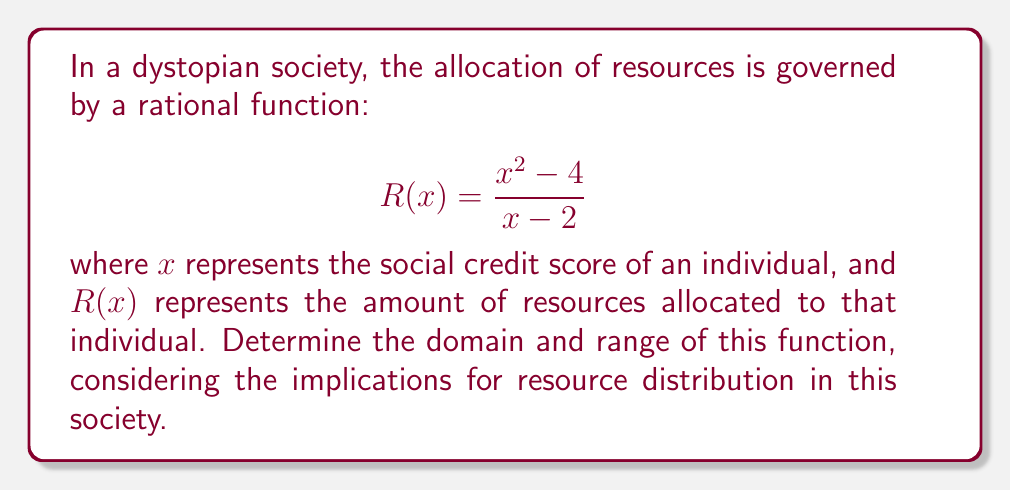Help me with this question. To find the domain and range of this rational function, we need to follow these steps:

1. Domain:
   The domain consists of all real numbers except those that make the denominator zero.
   Set the denominator to zero and solve:
   $x - 2 = 0$
   $x = 2$
   Therefore, the domain is all real numbers except 2, or $x \in \mathbb{R} \setminus \{2\}$.

2. Range:
   a) Rewrite the function in the form $y = R(x)$:
      $y = \frac{x^2 - 4}{x - 2}$

   b) Multiply both sides by $(x - 2)$:
      $y(x - 2) = x^2 - 4$

   c) Expand:
      $yx - 2y = x^2 - 4$

   d) Rearrange to standard form:
      $x^2 - yx + (2y - 4) = 0$

   e) For this to have one solution (tangent point), the discriminant must be zero:
      $b^2 - 4ac = 0$
      $(-y)^2 - 4(1)(2y - 4) = 0$
      $y^2 - 8y + 16 = 0$
      $(y - 4)^2 = 0$
      $y = 4$

   f) This means the function will approach but never reach $y = 4$.

   g) As $x$ approaches $\pm\infty$, the function approaches $\pm\infty$.

Therefore, the range is all real numbers except 4, or $y \in \mathbb{R} \setminus \{4\}$.

In the context of this dystopian society, this means that individuals with a social credit score of 2 are excluded from resource allocation, and there's a maximum resource limit that can never quite be reached, regardless of how high an individual's social credit score becomes.
Answer: Domain: $x \in \mathbb{R} \setminus \{2\}$, Range: $y \in \mathbb{R} \setminus \{4\}$ 